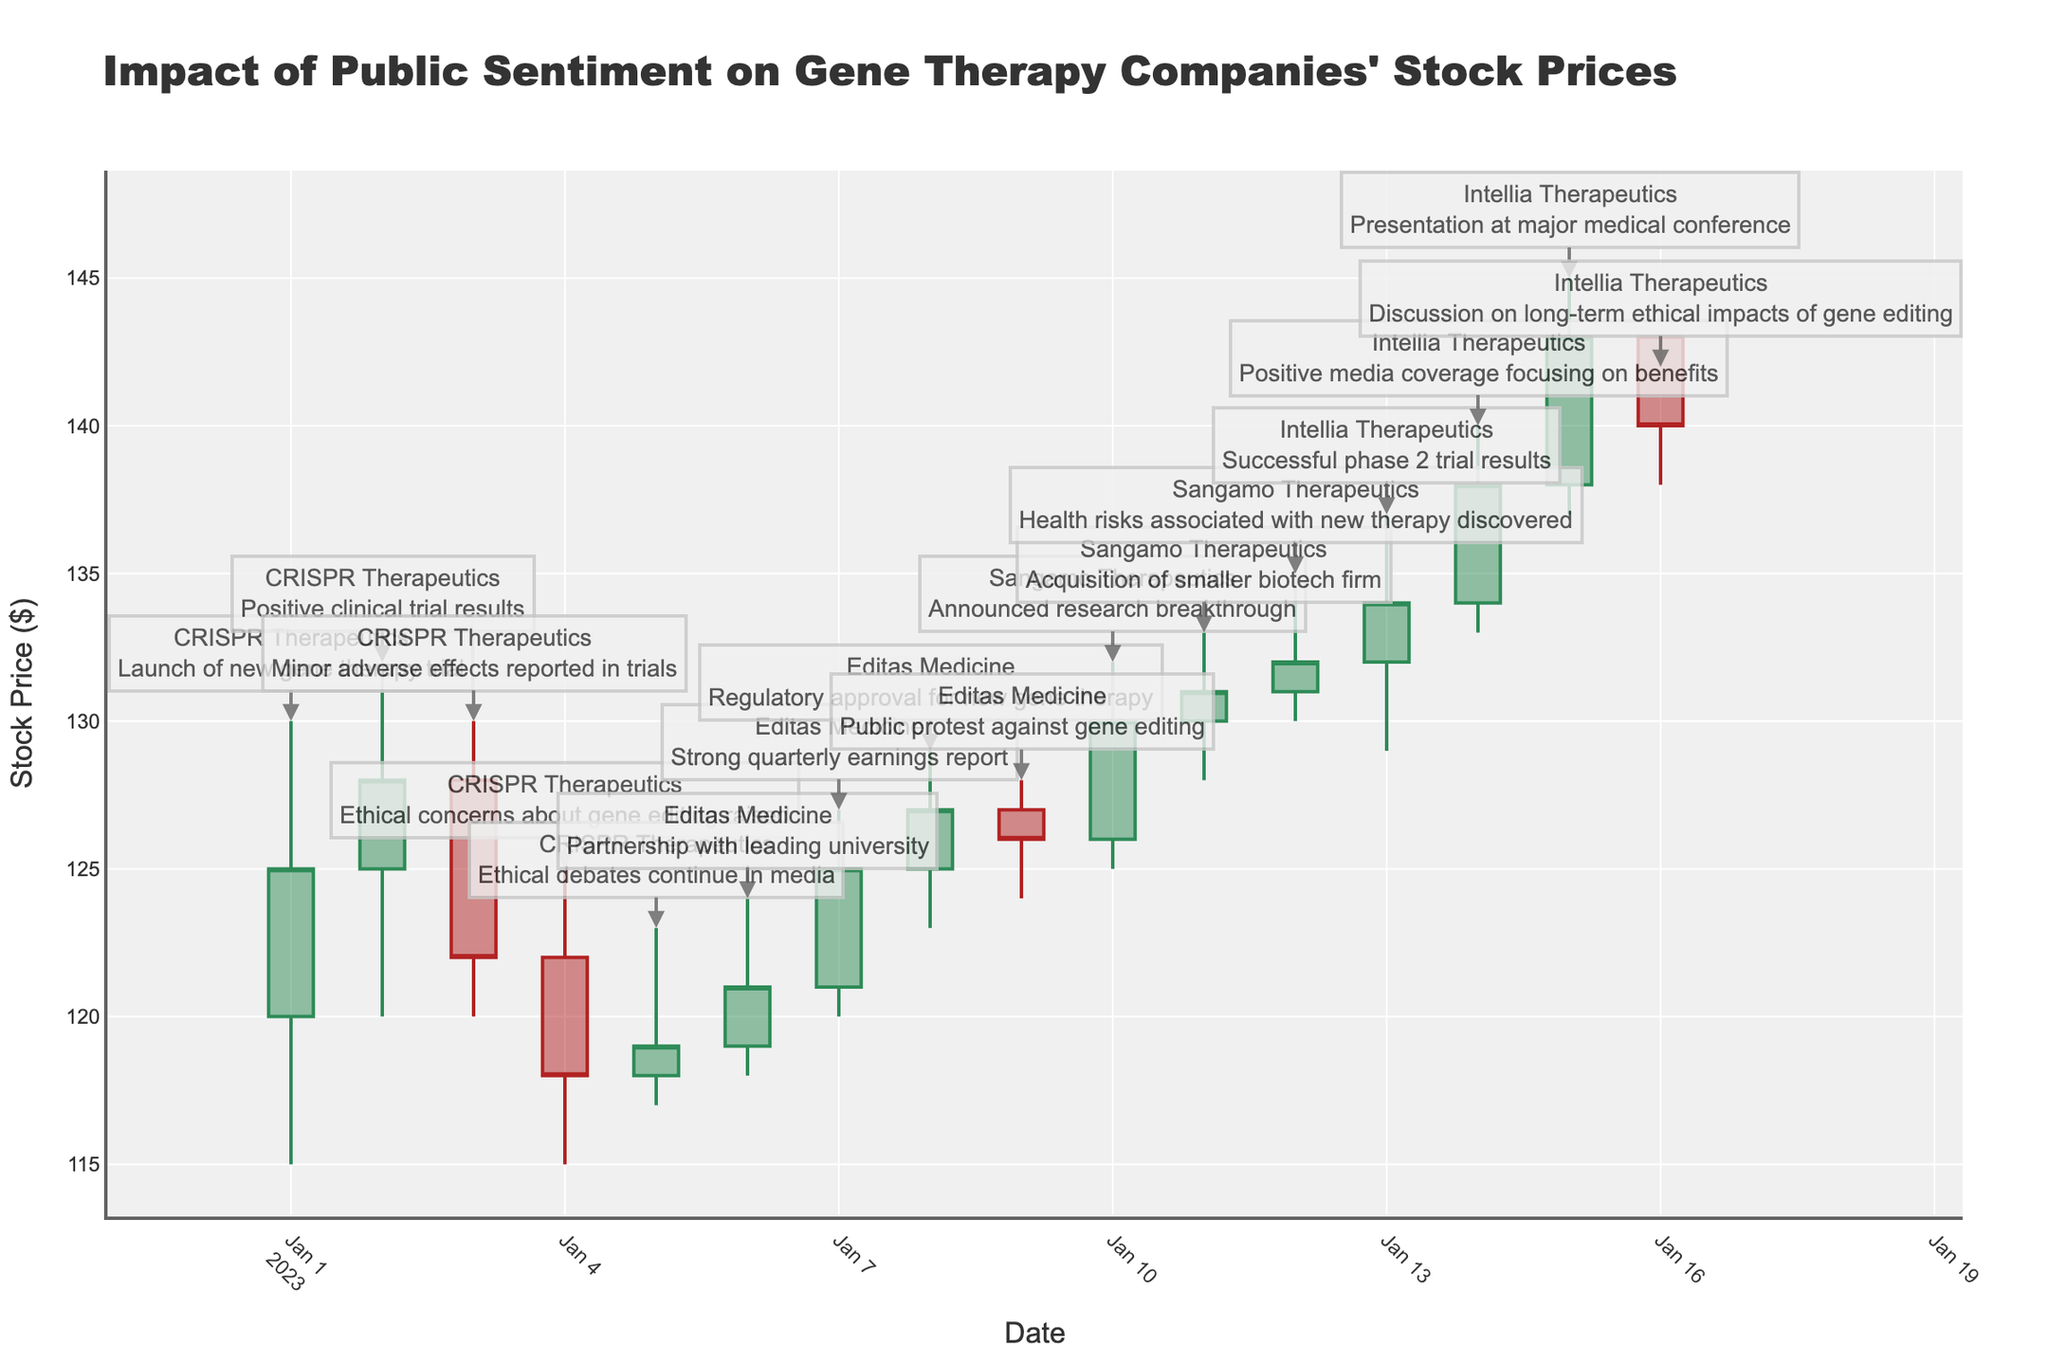What is the title of the plot? Look at the main heading at the top of the chart to find the title. It is clearly printed and easily identifiable.
Answer: Impact of Public Sentiment on Gene Therapy Companies' Stock Prices What is the stock price range for CRISPR Therapeutics on January 1? Check the candlestick for January 1. The highest and lowest points of the candlestick show the range of stock prices for that day.
Answer: 115 to 130 How did the stock price of Editas Medicine change between January 6 and January 7? Identify the starting price on January 6 and the ending price on January 7. Calculate the difference between these two prices to determine the change.
Answer: Increased by 4 Which company reported positive clinical trial results, and what was the effect on its stock price? Find the annotation mentioning positive clinical trial results and note the associated company. Then observe the corresponding candlestick to see the change in stock price.
Answer: CRISPR Therapeutics, increased Compare the closing prices of Sangamo Therapeutics on January 10 and January 11. Which day had a higher closing price? Look at the closing prices for both days. The closing price is indicated by the line at the right side of the candlestick. Compare these two values.
Answer: January 11 How did negative public sentiment affect the stock prices of gene therapy companies? Identify annotations related to negative events and note the direction and magnitudes of the changes in the candlesticks for those days. Summarize the overall trend.
Answer: Generally decreased What event coincided with Intellia Therapeutics' highest closing price in the dataset? Find the highest closing price for Intellia Therapeutics and look at the annotation for that day to identify the corresponding event.
Answer: Presentation at major medical conference On which date did CRISPR Therapeutics experience a notable decrease in stock price due to ethical concerns? Locate the date for the ethical concerns event annotation and observe the candlestick for any notable decrease in stock price.
Answer: January 4 What was the outcome of Sangamo Therapeutics’ stock after announcing a research breakthrough on January 10? Examine the candlestick for January 10 to see how the stock price changed throughout the day, especially comparing open and close prices.
Answer: Increased What trend can be observed for Intellia Therapeutics’ stock prices following positive media coverage on January 14? Observe the candlesticks starting from January 14 and note the trend in closing prices over the following days. Summarize the pattern.
Answer: Increased then slightly decreased 